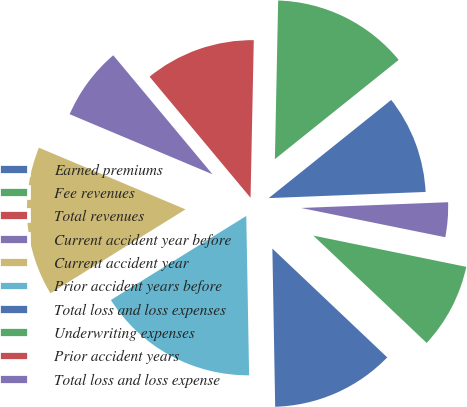Convert chart. <chart><loc_0><loc_0><loc_500><loc_500><pie_chart><fcel>Earned premiums<fcel>Fee revenues<fcel>Total revenues<fcel>Current accident year before<fcel>Current accident year<fcel>Prior accident years before<fcel>Total loss and loss expenses<fcel>Underwriting expenses<fcel>Prior accident years<fcel>Total loss and loss expense<nl><fcel>10.13%<fcel>13.92%<fcel>11.39%<fcel>7.6%<fcel>15.18%<fcel>16.44%<fcel>12.65%<fcel>8.86%<fcel>0.02%<fcel>3.81%<nl></chart> 